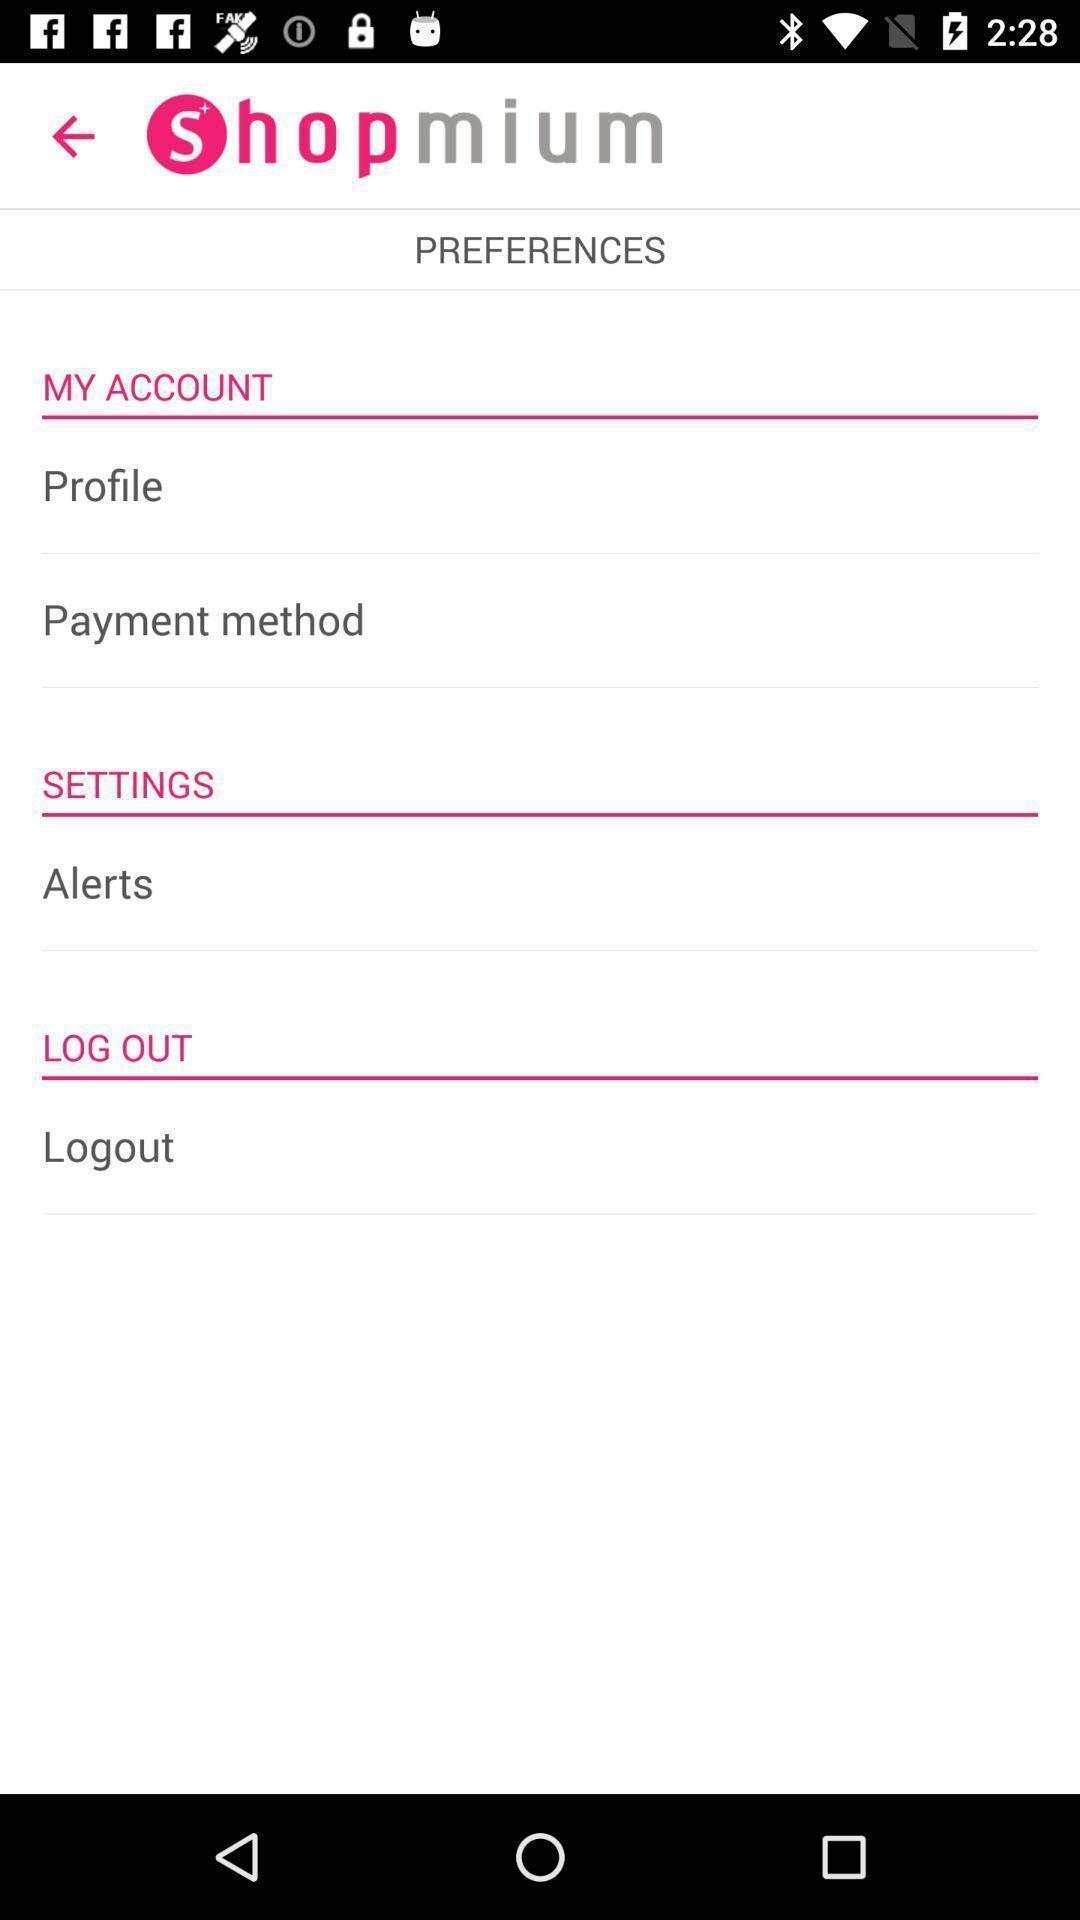Give me a summary of this screen capture. Screen showing preferences in application. 